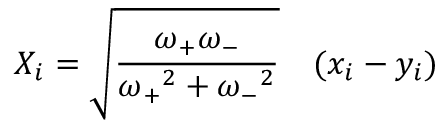Convert formula to latex. <formula><loc_0><loc_0><loc_500><loc_500>X _ { i } = { \sqrt { \frac { \omega _ { + } \omega _ { - } } { { \omega _ { + } } ^ { 2 } + { \omega _ { - } } ^ { 2 } } } } \quad ( x _ { i } - y _ { i } )</formula> 